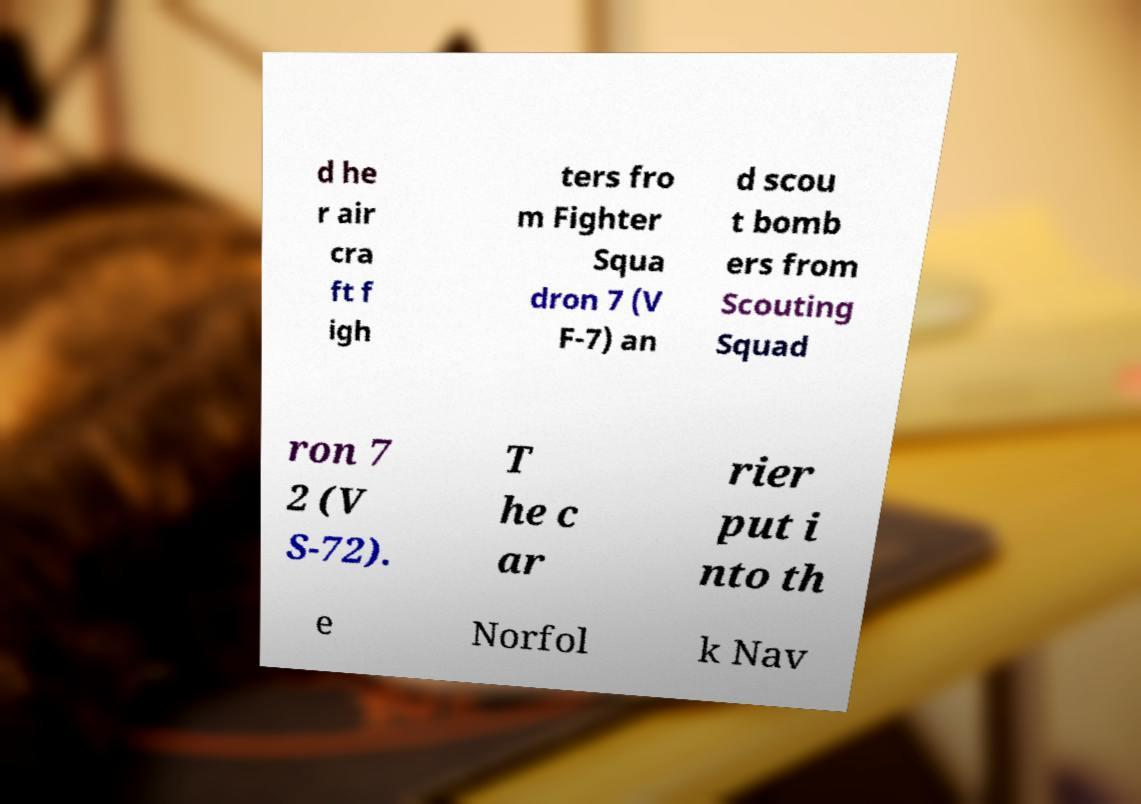Please identify and transcribe the text found in this image. d he r air cra ft f igh ters fro m Fighter Squa dron 7 (V F-7) an d scou t bomb ers from Scouting Squad ron 7 2 (V S-72). T he c ar rier put i nto th e Norfol k Nav 